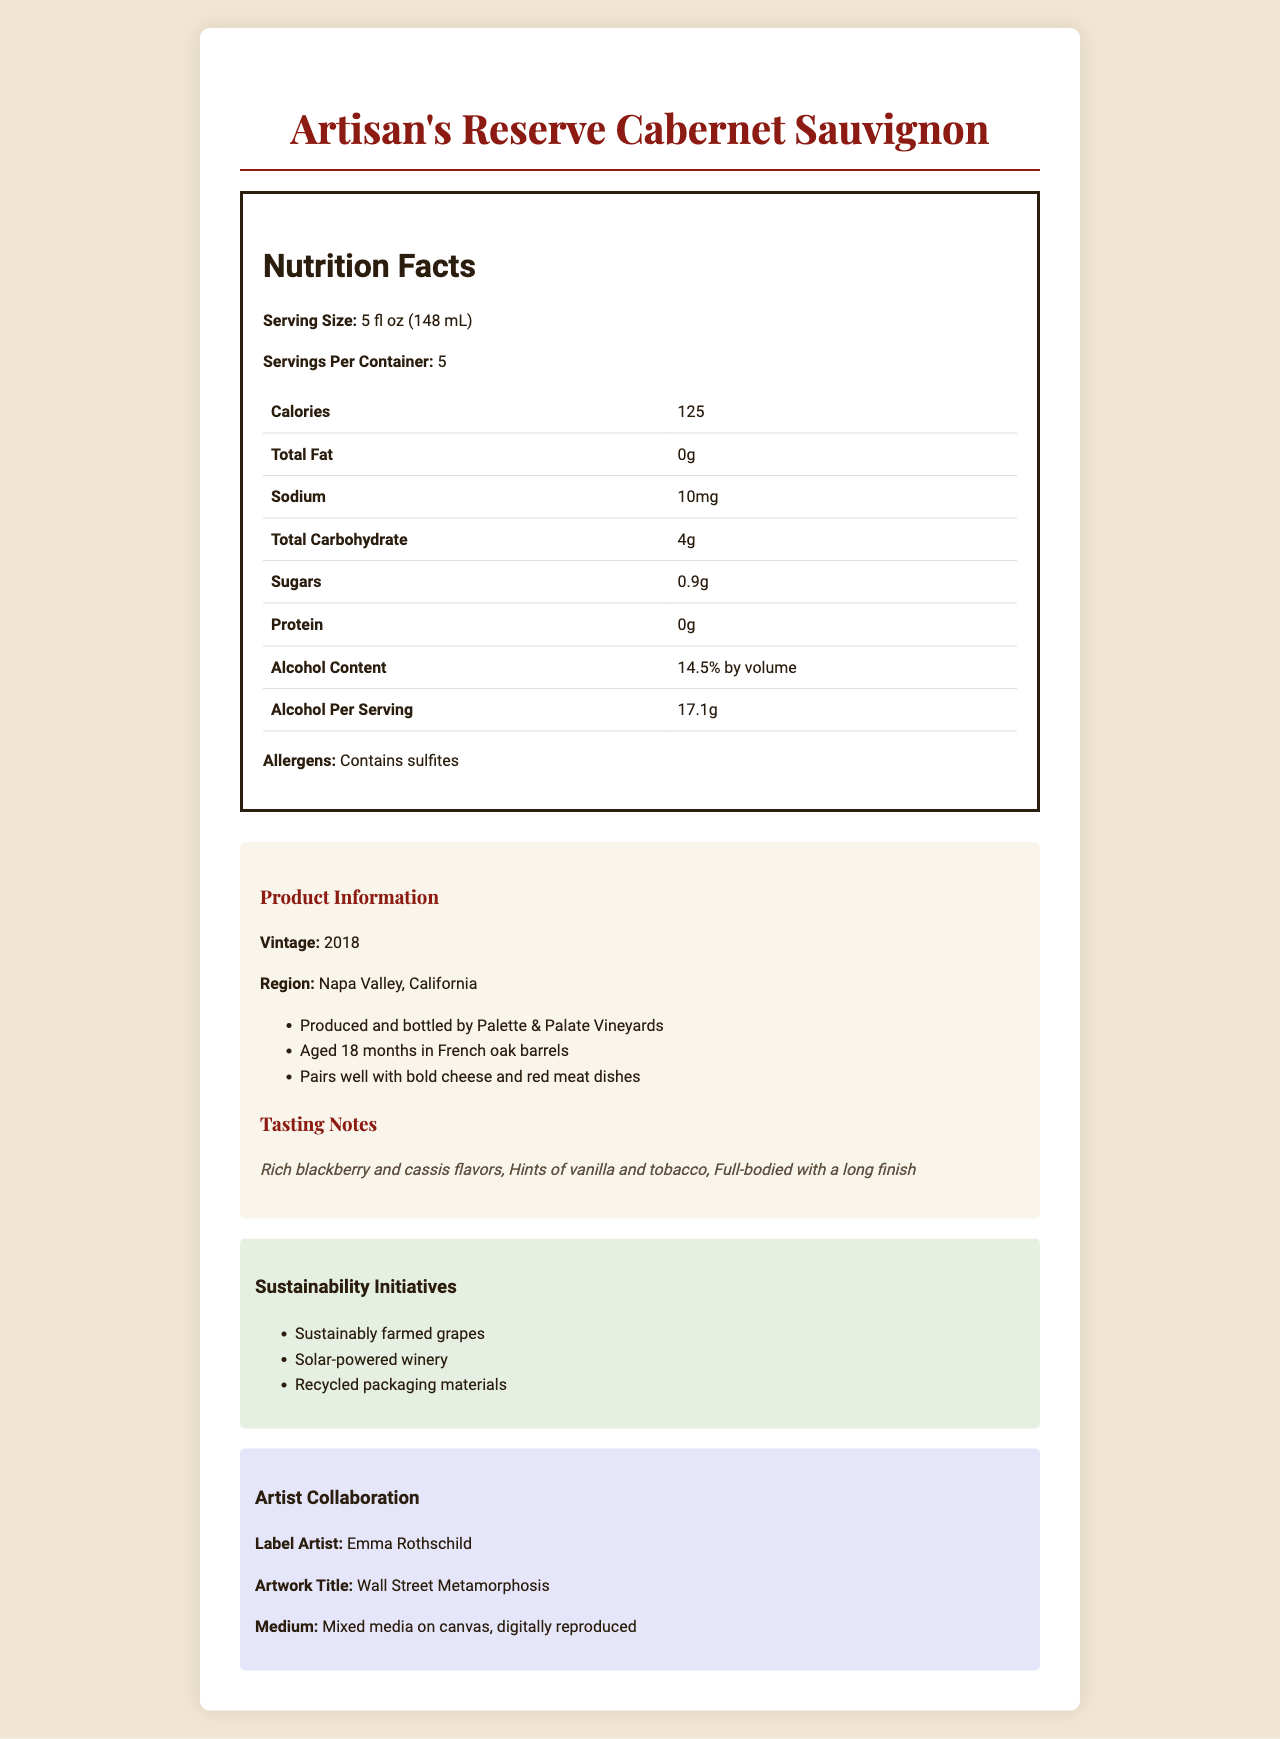what is the serving size of the wine? The document clearly states that the serving size of Artisan's Reserve Cabernet Sauvignon is 5 fl oz (148 mL).
Answer: 5 fl oz (148 mL) how many calories are there per serving? The nutrition facts table indicates that there are 125 calories per serving.
Answer: 125 what is the alcohol content by volume for this wine? The document lists the alcohol content as 14.5% by volume.
Answer: 14.5% by volume how much sugar is in one serving? The document states that there are 0.9 grams of sugar per serving.
Answer: 0.9g what are the tasting notes mentioned for this wine? The section on tasting notes describes these specific flavors and characteristics.
Answer: Rich blackberry and cassis flavors, Hints of vanilla and tobacco, Full-bodied with a long finish which allergens are present in the wine? The nutrition facts section lists sulfites as the allergen.
Answer: Contains sulfites what is the vintage year of the Artisan's Reserve Cabernet Sauvignon? The document indicates that the vintage year is 2018.
Answer: 2018 how many servings are there in one container? According to the document, there are 5 servings per container.
Answer: 5 which region is this wine from? The document specifies that the wine is from Napa Valley, California.
Answer: Napa Valley, California what medium was used by the label artist for the artwork? A. Oil paint B. Watercolor C. Mixed media D. Digital only The document states that the medium used by Emma Rothschild for the label artwork is mixed media on canvas, digitally reproduced.
Answer: C. Mixed media what is the suggested retail price per bottle? A. $22 B. $45 C. $65 D. $100 According to the financial data, the suggested retail price per bottle is $65.
Answer: C. $65 is the winery solar-powered? Yes/No The sustainability information mentions that the winery is solar-powered.
Answer: Yes summarize the main features and additional information about the Artisan's Reserve Cabernet Sauvignon from the document. This summary encapsulates the nutrition facts, product information, tasting notes, sustainability initiatives, and artist collaboration as detailed in the document.
Answer: The Artisan's Reserve Cabernet Sauvignon is a 2018 vintage wine from Napa Valley, California, with 14.5% alcohol by volume. It contains 125 calories per 5 fl oz (148 mL) serving, and allergens include sulfites. Produced by Palette & Palate Vineyards, it was aged for 18 months in French oak barrels. Tasting notes highlight rich blackberry and cassis flavors, with hints of vanilla and tobacco. The wine is packaged sustainably, and the label features artwork by Emma Rothschild titled "Wall Street Metamorphosis." what are the projected annual sales for this wine? The financial data section states that the projected annual sales are 10,000 cases.
Answer: 10,000 cases how much time was the wine aged in French oak barrels? The additional information section specifies that the wine was aged for 18 months in French oak barrels.
Answer: 18 months who is the artist for the label artwork? The artist collaboration section states that Emma Rothschild is the label artist.
Answer: Emma Rothschild what is the total carbohydrate content per serving? The nutrition facts table indicates that there are 4 grams of total carbohydrates per serving.
Answer: 4g what is the production cost per bottle? The financial data section lists the production cost as $22 per bottle.
Answer: $22 what is the alcohol per serving in grams? The nutrition facts table indicates that there are 17.1 grams of alcohol per serving.
Answer: 17.1g when was the winery established? The document does not provide information on when the winery was established.
Answer: Cannot be determined 